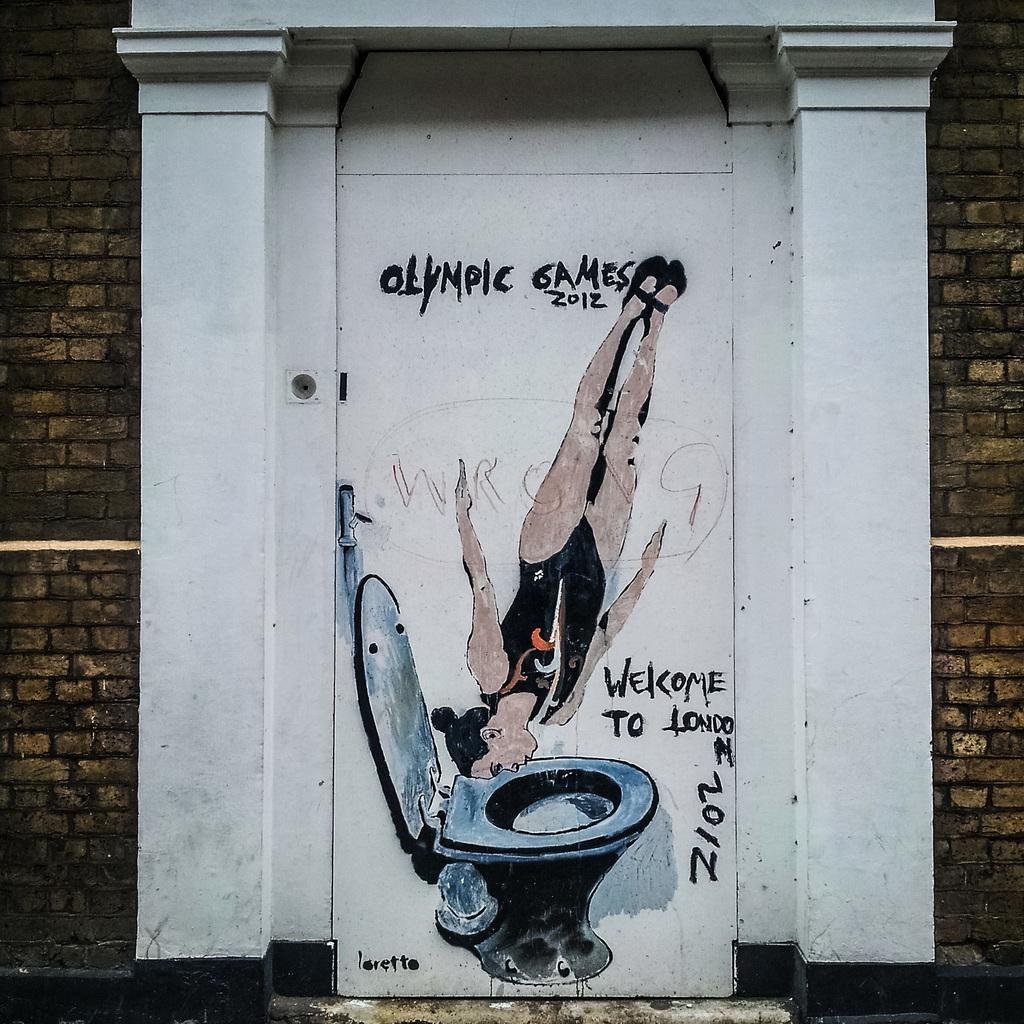<image>
Share a concise interpretation of the image provided. A person diving into a toilet has a Olympic Games welcome for 2012. 